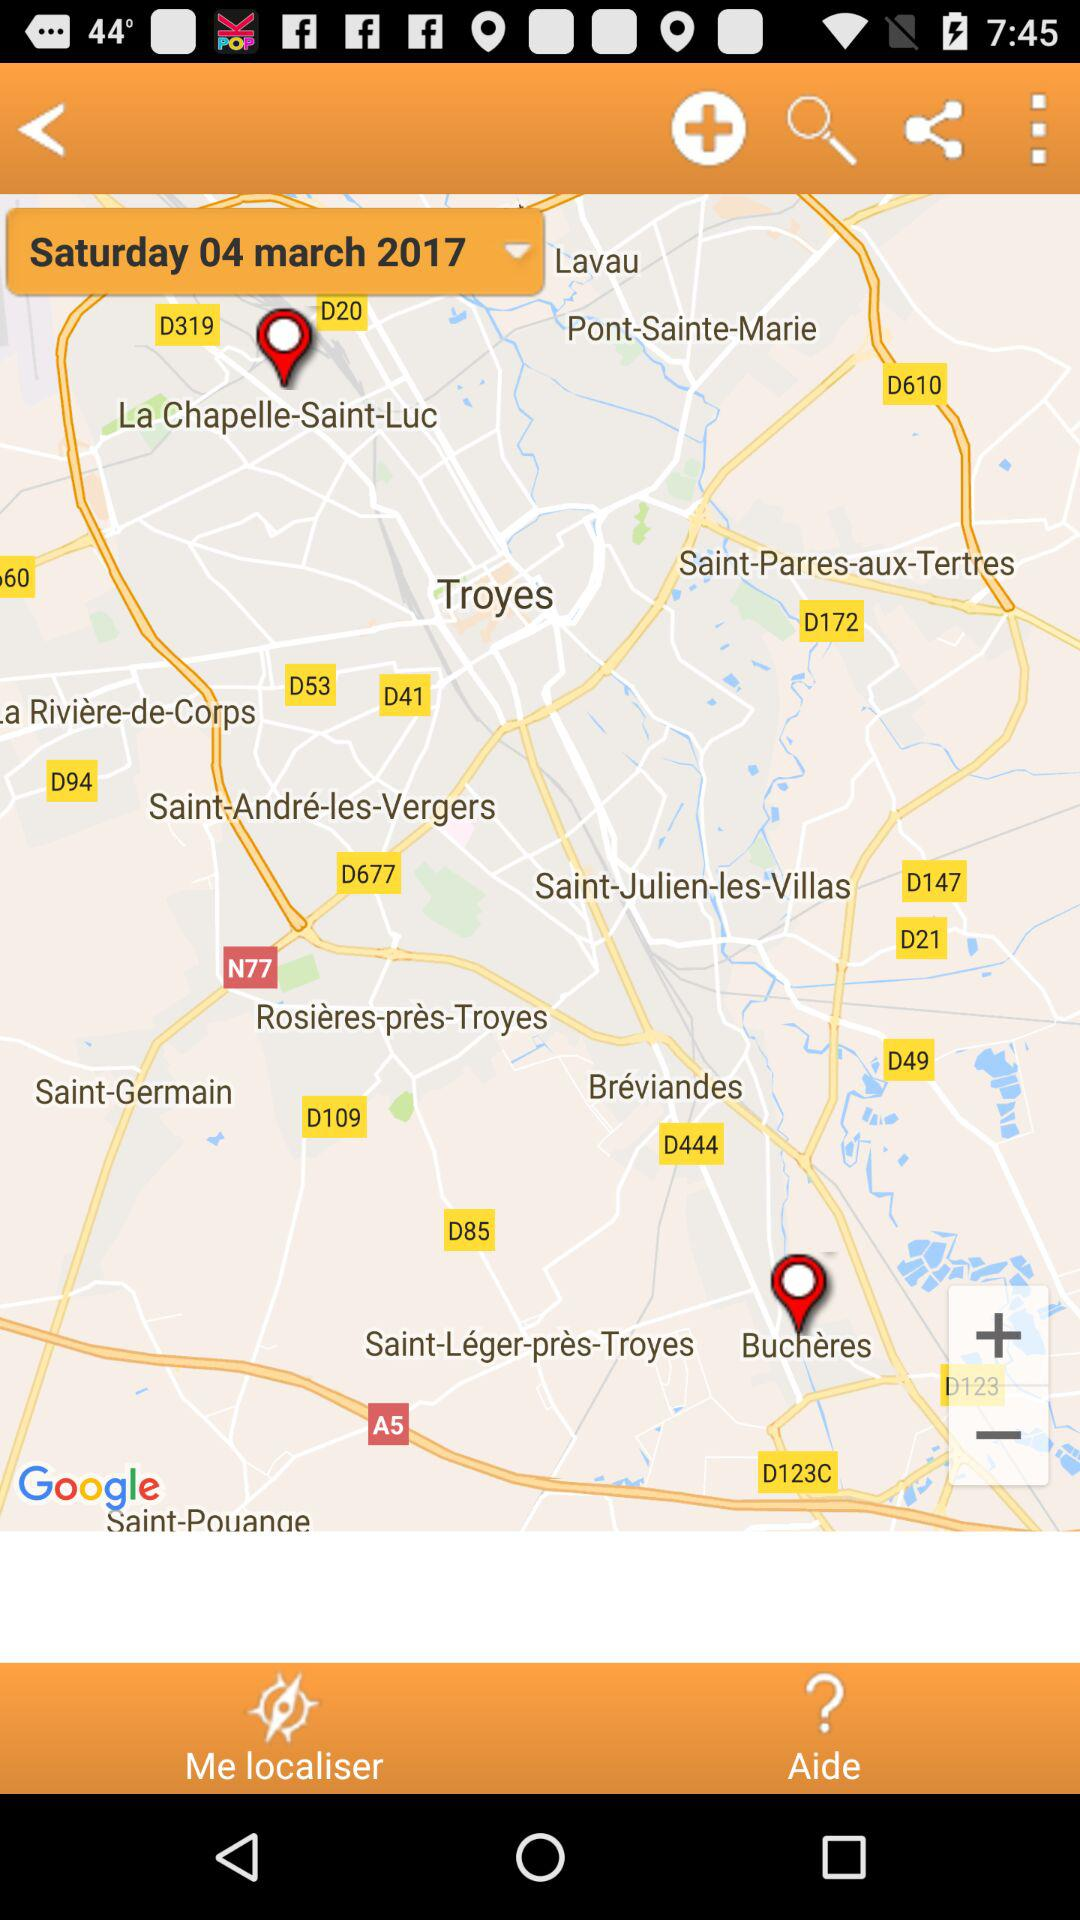What day falls on March 04, 2017? The day is "Saturday". 